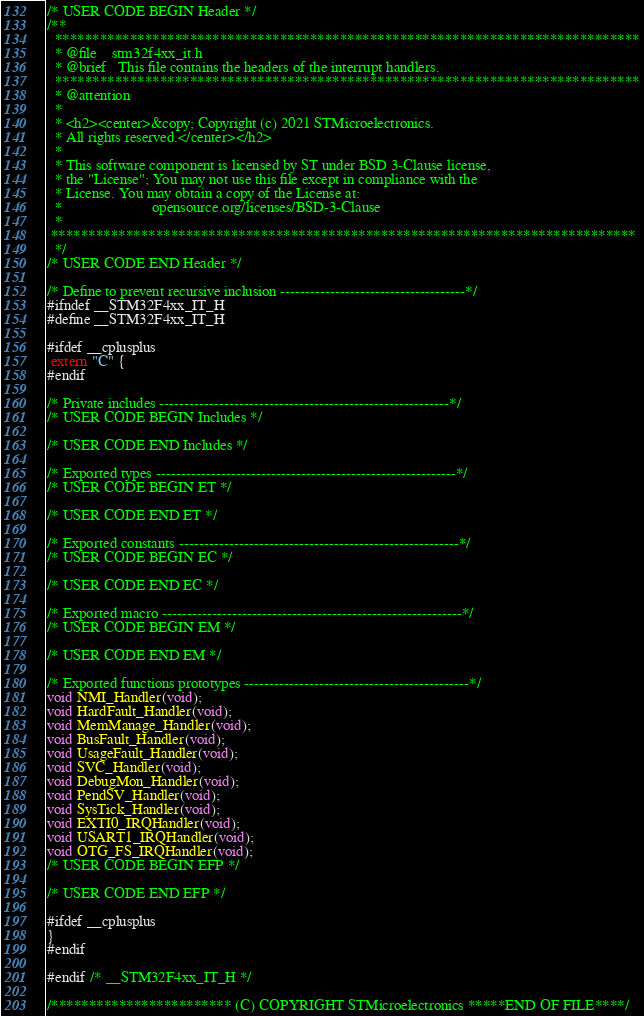Convert code to text. <code><loc_0><loc_0><loc_500><loc_500><_C_>/* USER CODE BEGIN Header */
/**
  ******************************************************************************
  * @file    stm32f4xx_it.h
  * @brief   This file contains the headers of the interrupt handlers.
  ******************************************************************************
  * @attention
  *
  * <h2><center>&copy; Copyright (c) 2021 STMicroelectronics.
  * All rights reserved.</center></h2>
  *
  * This software component is licensed by ST under BSD 3-Clause license,
  * the "License"; You may not use this file except in compliance with the
  * License. You may obtain a copy of the License at:
  *                        opensource.org/licenses/BSD-3-Clause
  *
 ******************************************************************************
  */
/* USER CODE END Header */

/* Define to prevent recursive inclusion -------------------------------------*/
#ifndef __STM32F4xx_IT_H
#define __STM32F4xx_IT_H

#ifdef __cplusplus
 extern "C" {
#endif

/* Private includes ----------------------------------------------------------*/
/* USER CODE BEGIN Includes */

/* USER CODE END Includes */

/* Exported types ------------------------------------------------------------*/
/* USER CODE BEGIN ET */

/* USER CODE END ET */

/* Exported constants --------------------------------------------------------*/
/* USER CODE BEGIN EC */

/* USER CODE END EC */

/* Exported macro ------------------------------------------------------------*/
/* USER CODE BEGIN EM */

/* USER CODE END EM */

/* Exported functions prototypes ---------------------------------------------*/
void NMI_Handler(void);
void HardFault_Handler(void);
void MemManage_Handler(void);
void BusFault_Handler(void);
void UsageFault_Handler(void);
void SVC_Handler(void);
void DebugMon_Handler(void);
void PendSV_Handler(void);
void SysTick_Handler(void);
void EXTI0_IRQHandler(void);
void USART1_IRQHandler(void);
void OTG_FS_IRQHandler(void);
/* USER CODE BEGIN EFP */

/* USER CODE END EFP */

#ifdef __cplusplus
}
#endif

#endif /* __STM32F4xx_IT_H */

/************************ (C) COPYRIGHT STMicroelectronics *****END OF FILE****/
</code> 